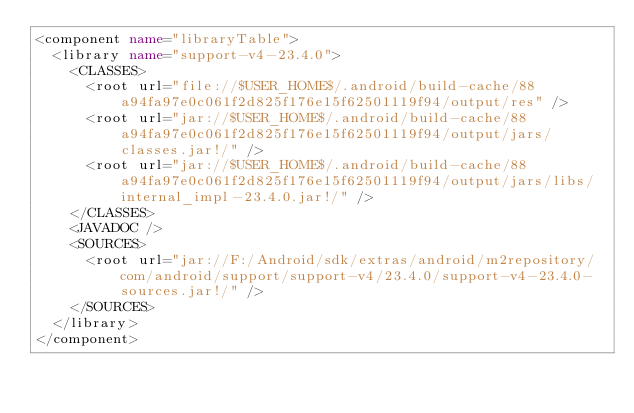Convert code to text. <code><loc_0><loc_0><loc_500><loc_500><_XML_><component name="libraryTable">
  <library name="support-v4-23.4.0">
    <CLASSES>
      <root url="file://$USER_HOME$/.android/build-cache/88a94fa97e0c061f2d825f176e15f62501119f94/output/res" />
      <root url="jar://$USER_HOME$/.android/build-cache/88a94fa97e0c061f2d825f176e15f62501119f94/output/jars/classes.jar!/" />
      <root url="jar://$USER_HOME$/.android/build-cache/88a94fa97e0c061f2d825f176e15f62501119f94/output/jars/libs/internal_impl-23.4.0.jar!/" />
    </CLASSES>
    <JAVADOC />
    <SOURCES>
      <root url="jar://F:/Android/sdk/extras/android/m2repository/com/android/support/support-v4/23.4.0/support-v4-23.4.0-sources.jar!/" />
    </SOURCES>
  </library>
</component></code> 